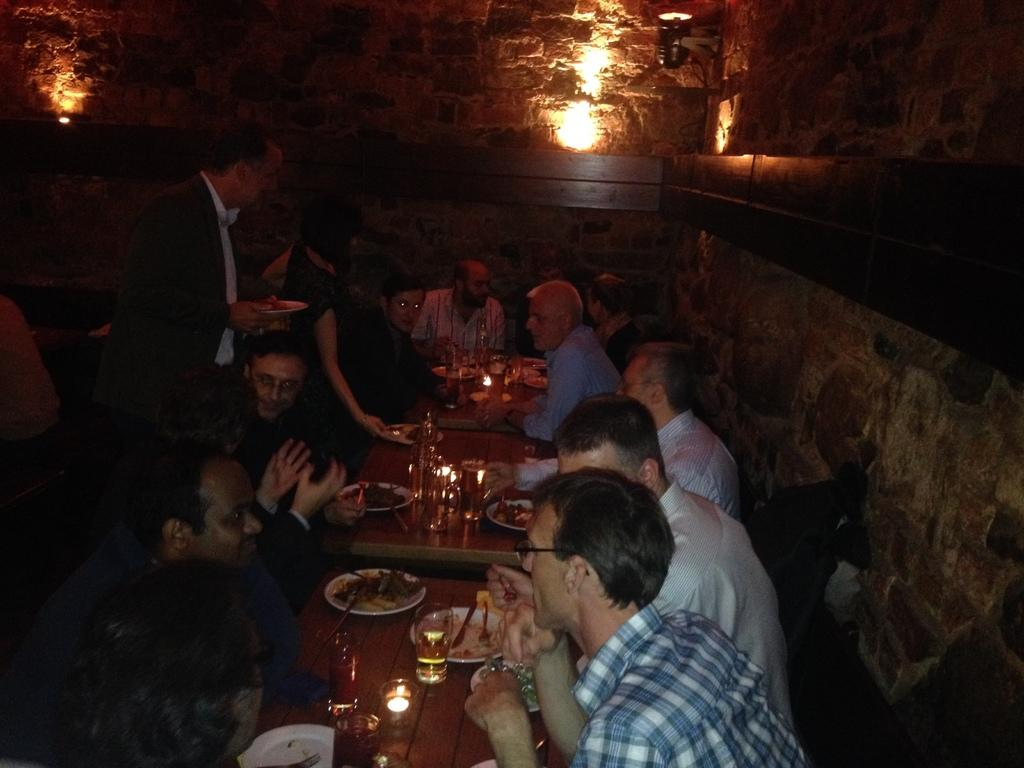What are the people in the image doing? The people in the image are sitting in chairs around a table. What objects are placed on the table? Plates and glasses are placed on the table. Is there anyone standing in the image? Yes, one person is standing. What can be seen in the background of the image? There is a light and a wall in the background. How many giants are present in the image? There are no giants present in the image. What type of book is the person reading at the table? There is no book visible in the image, and no one is reading. 